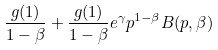<formula> <loc_0><loc_0><loc_500><loc_500>\frac { g ( 1 ) } { 1 - \beta } + \frac { g ( 1 ) } { 1 - \beta } e ^ { \gamma } p ^ { 1 - \beta } B ( p , \beta )</formula> 